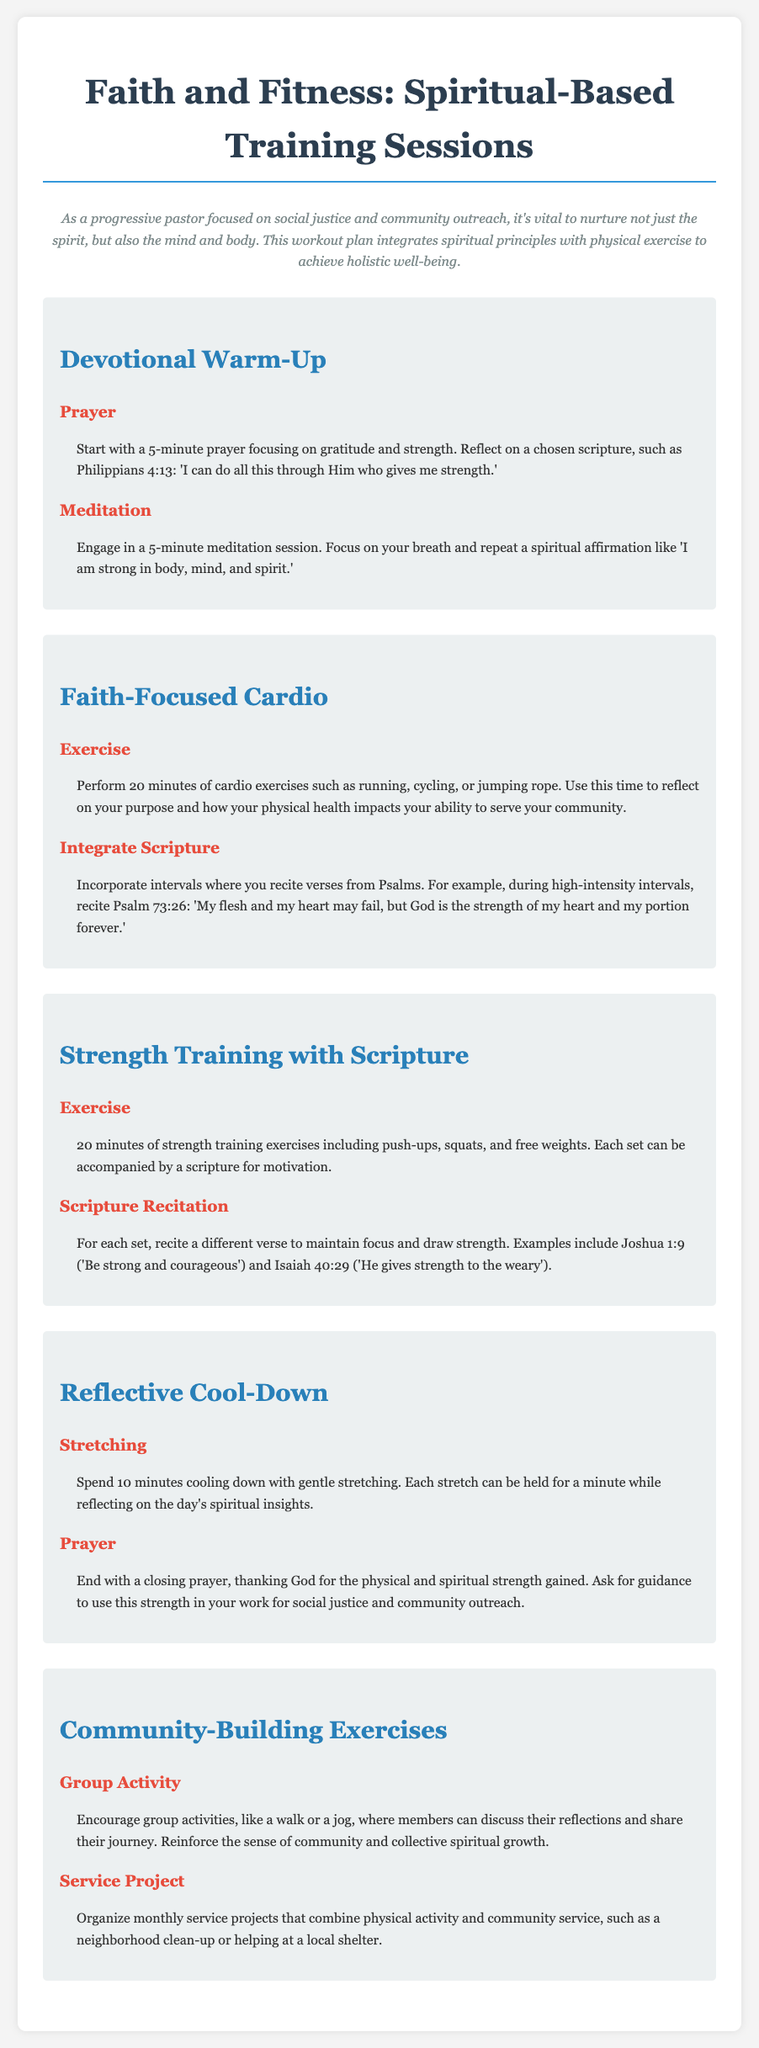what is the title of the document? The title of the document is presented at the top in large font.
Answer: Faith and Fitness: Spiritual-Based Training Sessions how long is the devotional warm-up? Devotional warm-up consists of a prayer and meditation, each lasting 5 minutes.
Answer: 10 minutes what scripture is suggested for the prayer? The scripture is used during the prayer to focus on gratitude and strength.
Answer: Philippians 4:13 how many minutes are dedicated to cardio exercises? The cardio exercise section specifies a duration presented in minutes.
Answer: 20 minutes what type of community-building exercise is included? Community activities mentioned encourage collaboration and discussion among members.
Answer: Group Activity which verse is recited for motivation during strength training? A specific verse is suggested to accompany each set of strength training.
Answer: Joshua 1:9 what is the focus of the reflective cool-down? It involves a gentle stretching routine that incorporates spiritual insights.
Answer: Stretching how often are the service projects organized? The document indicates the frequency of the community service projects.
Answer: Monthly what is the primary purpose of this workout plan? The primary purpose is articulated in the introduction and combines spiritual and physical wellness.
Answer: Holistic well-being 